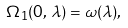Convert formula to latex. <formula><loc_0><loc_0><loc_500><loc_500>\Omega _ { 1 } ( 0 , \, \lambda ) = \omega ( \lambda ) ,</formula> 